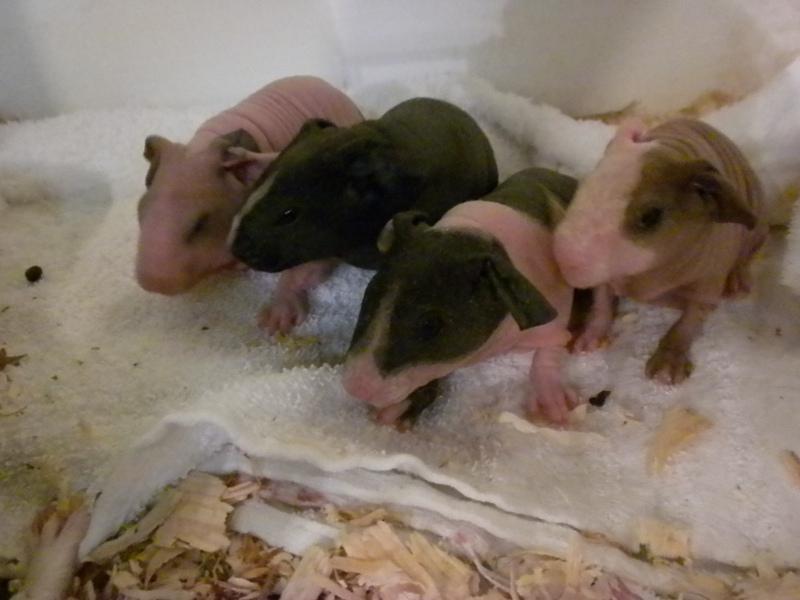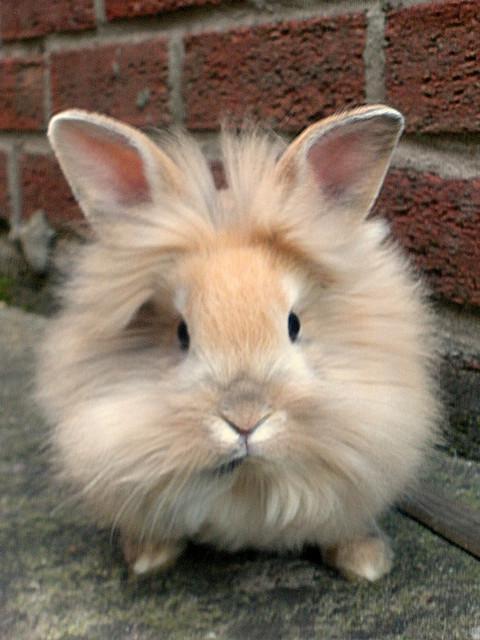The first image is the image on the left, the second image is the image on the right. Analyze the images presented: Is the assertion "there are guinea pigs on straw hay in a wooden pen" valid? Answer yes or no. No. The first image is the image on the left, the second image is the image on the right. Analyze the images presented: Is the assertion "At least one guinea pig is looking straight ahead." valid? Answer yes or no. Yes. 